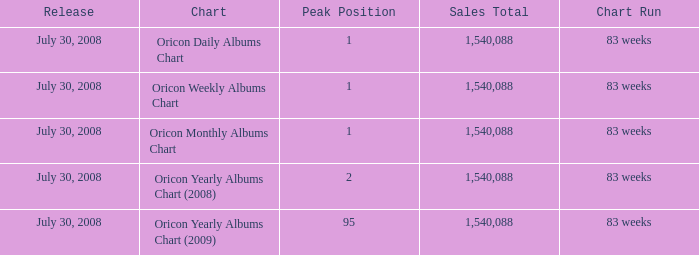What is the number of peak positions with a sales total greater than 1,540,088? 0.0. 